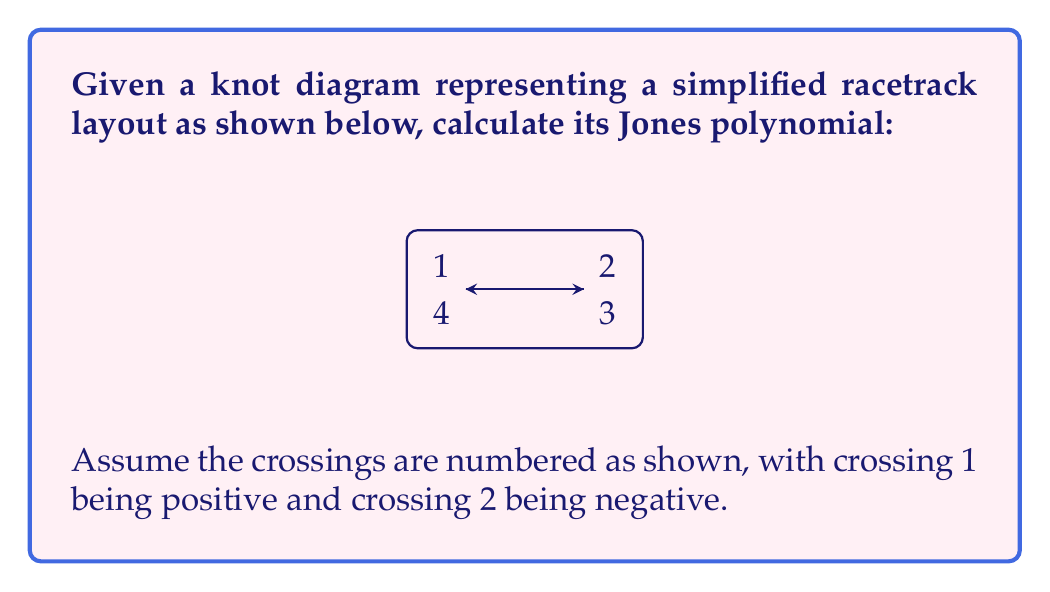Provide a solution to this math problem. To calculate the Jones polynomial of this knot, we'll use the skein relation and follow these steps:

1) First, let's recall the skein relation for the Jones polynomial:

   $$t^{-1}V(L_+) - tV(L_-) = (t^{1/2} - t^{-1/2})V(L_0)$$

   where $L_+$, $L_-$, and $L_0$ represent positive crossing, negative crossing, and no crossing respectively.

2) We'll start by focusing on crossing 1. Let $L$ be our original knot, $L_-$ be the knot with crossing 1 changed to negative, and $L_0$ be the knot with crossing 1 removed.

3) Applying the skein relation:

   $$t^{-1}V(L) - tV(L_-) = (t^{1/2} - t^{-1/2})V(L_0)$$

4) Now, $L_-$ is the unknot (all crossings cancel out), so $V(L_-) = 1$.

5) $L_0$ is also the unknot, so $V(L_0) = 1$.

6) Substituting these values:

   $$t^{-1}V(L) - t = t^{1/2} - t^{-1/2}$$

7) Solving for $V(L)$:

   $$V(L) = t(t^{1/2} - t^{-1/2}) + t^2 = t^{3/2} - t^{1/2} + t^2$$

8) This is the Jones polynomial of our racetrack knot.
Answer: $V(L) = t^{3/2} - t^{1/2} + t^2$ 